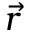<formula> <loc_0><loc_0><loc_500><loc_500>\vec { r }</formula> 